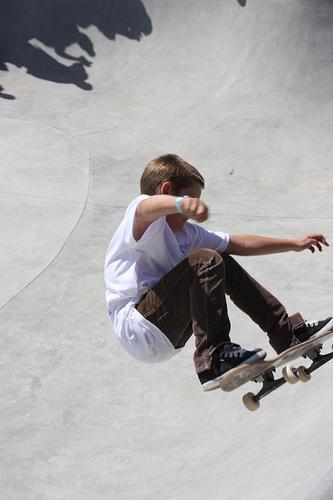What kind of clothing is the boy wearing?
Keep it brief. T shirt and jeans. What is the person standing on?
Write a very short answer. Skateboard. What color is the ground?
Write a very short answer. Gray. Based on the texture of the ground around him, If this boy fell would it hurt him?
Short answer required. Yes. What is the man doing?
Be succinct. Skateboarding. Does this activity require snow?
Quick response, please. No. Is this kid skateboarding?
Answer briefly. Yes. What color are the kids shoes?
Keep it brief. Black. 